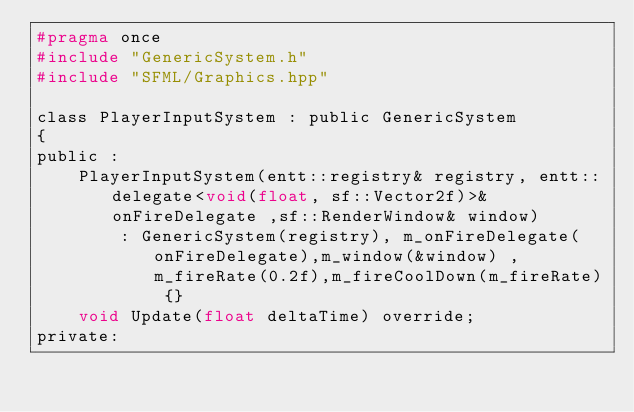Convert code to text. <code><loc_0><loc_0><loc_500><loc_500><_C_>#pragma once
#include "GenericSystem.h"
#include "SFML/Graphics.hpp"

class PlayerInputSystem : public GenericSystem 
{
public :
	PlayerInputSystem(entt::registry& registry, entt::delegate<void(float, sf::Vector2f)>& onFireDelegate ,sf::RenderWindow& window)
		: GenericSystem(registry), m_onFireDelegate(onFireDelegate),m_window(&window) , m_fireRate(0.2f),m_fireCoolDown(m_fireRate) {}
	void Update(float deltaTime) override;
private:</code> 